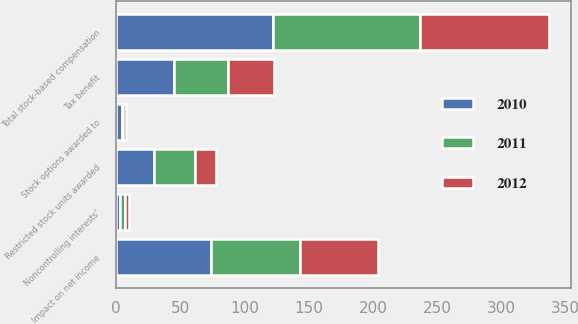Convert chart to OTSL. <chart><loc_0><loc_0><loc_500><loc_500><stacked_bar_chart><ecel><fcel>Stock options awarded to<fcel>Restricted stock units awarded<fcel>Total stock-based compensation<fcel>Tax benefit<fcel>Noncontrolling interests'<fcel>Impact on net income<nl><fcel>2012<fcel>2<fcel>16<fcel>100<fcel>36<fcel>3<fcel>61<nl><fcel>2011<fcel>1<fcel>32<fcel>115<fcel>42<fcel>4<fcel>69<nl><fcel>2010<fcel>5<fcel>30<fcel>122<fcel>45<fcel>3<fcel>74<nl></chart> 